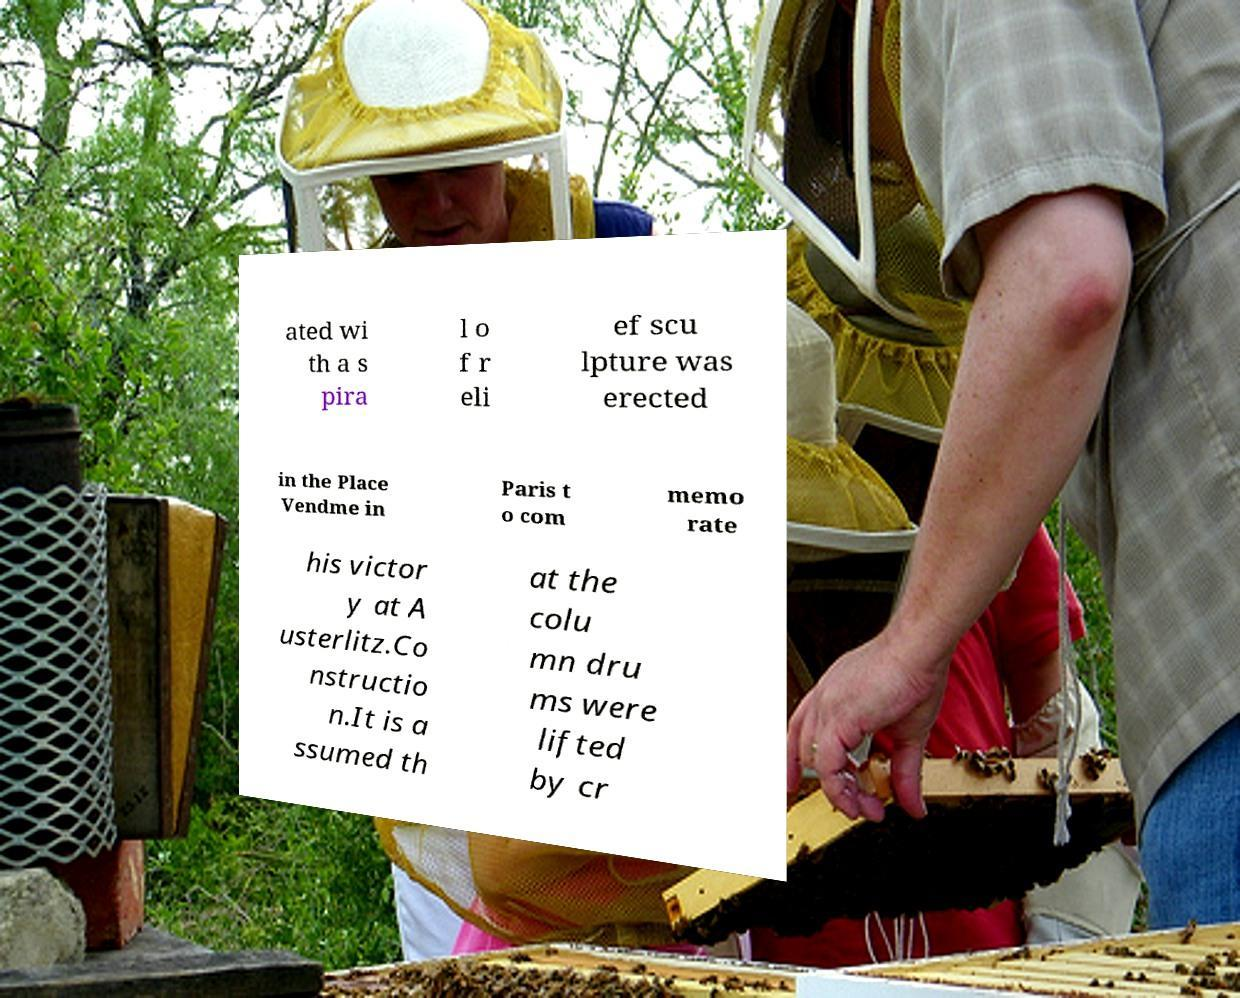Could you extract and type out the text from this image? ated wi th a s pira l o f r eli ef scu lpture was erected in the Place Vendme in Paris t o com memo rate his victor y at A usterlitz.Co nstructio n.It is a ssumed th at the colu mn dru ms were lifted by cr 